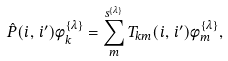Convert formula to latex. <formula><loc_0><loc_0><loc_500><loc_500>\hat { P } ( i , \, i ^ { \prime } ) \phi ^ { \{ \lambda \} } _ { k } = \sum _ { m } ^ { s ^ { \{ \lambda \} } } T _ { k m } ( i , \, i ^ { \prime } ) \phi ^ { \{ \lambda \} } _ { m } ,</formula> 